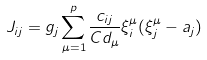Convert formula to latex. <formula><loc_0><loc_0><loc_500><loc_500>J _ { i j } = g _ { j } \sum _ { \mu = 1 } ^ { p } \frac { c _ { i j } } { C d _ { \mu } } \xi _ { i } ^ { \mu } ( \xi _ { j } ^ { \mu } - a _ { j } )</formula> 